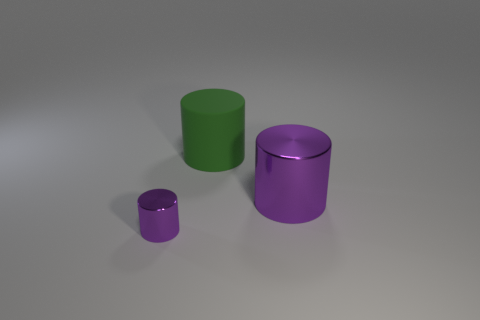How might these cylinders be categorized in terms of visual hierarchy? The visual hierarchy among the cylinders can be discussed in terms of size, color, and finish. The largest matte purple cylinder dominates the visual field due to its size and could be considered the primary focus. The medium green cylinder serves as a secondary focal point because of its bright color and moderate size. Lastly, the small glossy purple cylinder could be viewed as a tertiary element due to its small size, but its glossy finish also attracts the eye, which balances its impact in the visual hierarchy. 